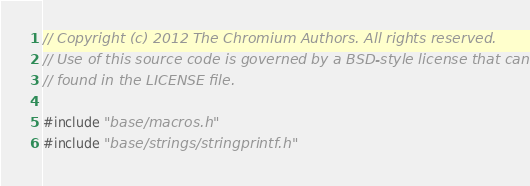<code> <loc_0><loc_0><loc_500><loc_500><_C++_>// Copyright (c) 2012 The Chromium Authors. All rights reserved.
// Use of this source code is governed by a BSD-style license that can be
// found in the LICENSE file.

#include "base/macros.h"
#include "base/strings/stringprintf.h"</code> 